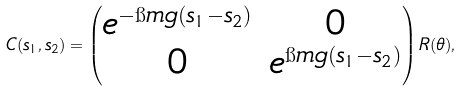<formula> <loc_0><loc_0><loc_500><loc_500>C ( s _ { 1 } , s _ { 2 } ) = \begin{pmatrix} e ^ { - \i m g ( s _ { 1 } - s _ { 2 } ) } & 0 \\ 0 & e ^ { \i m g ( s _ { 1 } - s _ { 2 } ) } \end{pmatrix} R ( \theta ) ,</formula> 